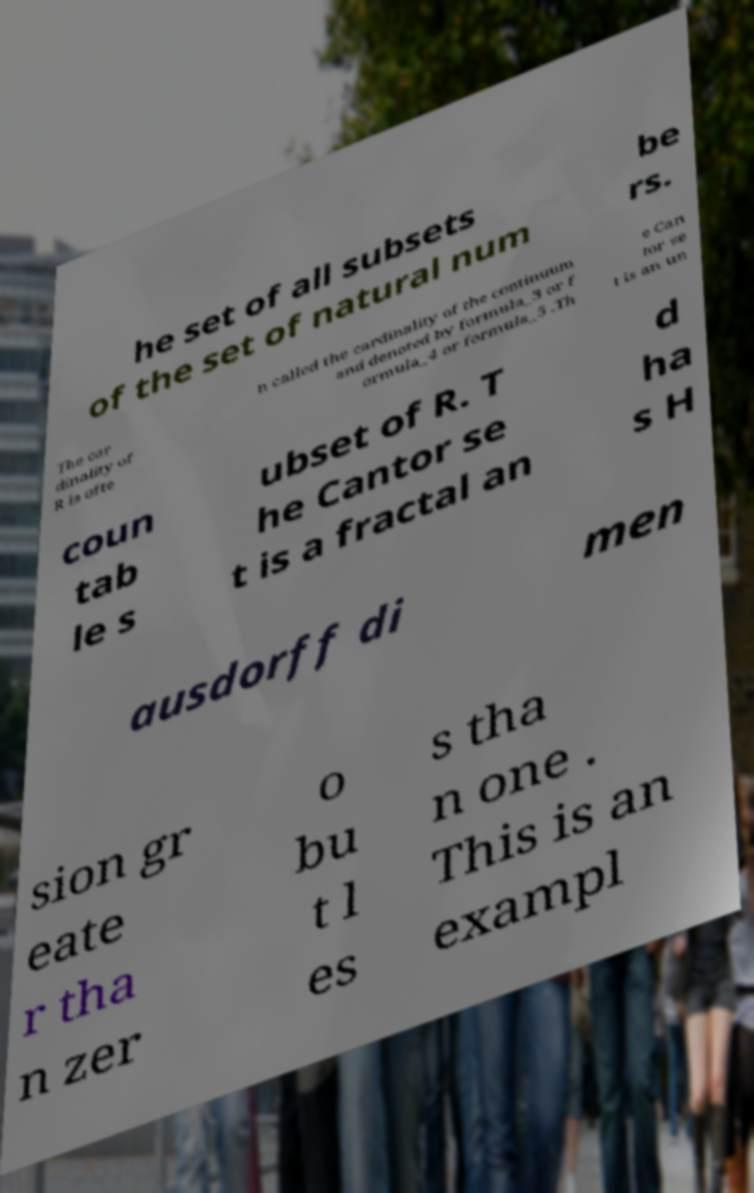Can you read and provide the text displayed in the image?This photo seems to have some interesting text. Can you extract and type it out for me? he set of all subsets of the set of natural num be rs. The car dinality of R is ofte n called the cardinality of the continuum and denoted by formula_3 or f ormula_4 or formula_5 .Th e Can tor se t is an un coun tab le s ubset of R. T he Cantor se t is a fractal an d ha s H ausdorff di men sion gr eate r tha n zer o bu t l es s tha n one . This is an exampl 